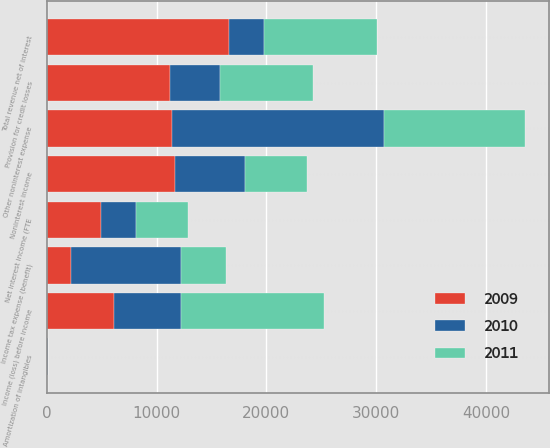<chart> <loc_0><loc_0><loc_500><loc_500><stacked_bar_chart><ecel><fcel>Net interest income (FTE<fcel>Noninterest income<fcel>Total revenue net of interest<fcel>Provision for credit losses<fcel>Amortization of intangibles<fcel>Other noninterest expense<fcel>Income (loss) before income<fcel>Income tax expense (benefit)<nl><fcel>2010<fcel>3207<fcel>6361<fcel>3154<fcel>4524<fcel>11<fcel>19279<fcel>6106<fcel>10042<nl><fcel>2011<fcel>4662<fcel>5667<fcel>10329<fcel>8490<fcel>38<fcel>12848<fcel>13047<fcel>4100<nl><fcel>2009<fcel>4961<fcel>11677<fcel>16638<fcel>11244<fcel>63<fcel>11437<fcel>6106<fcel>2217<nl></chart> 